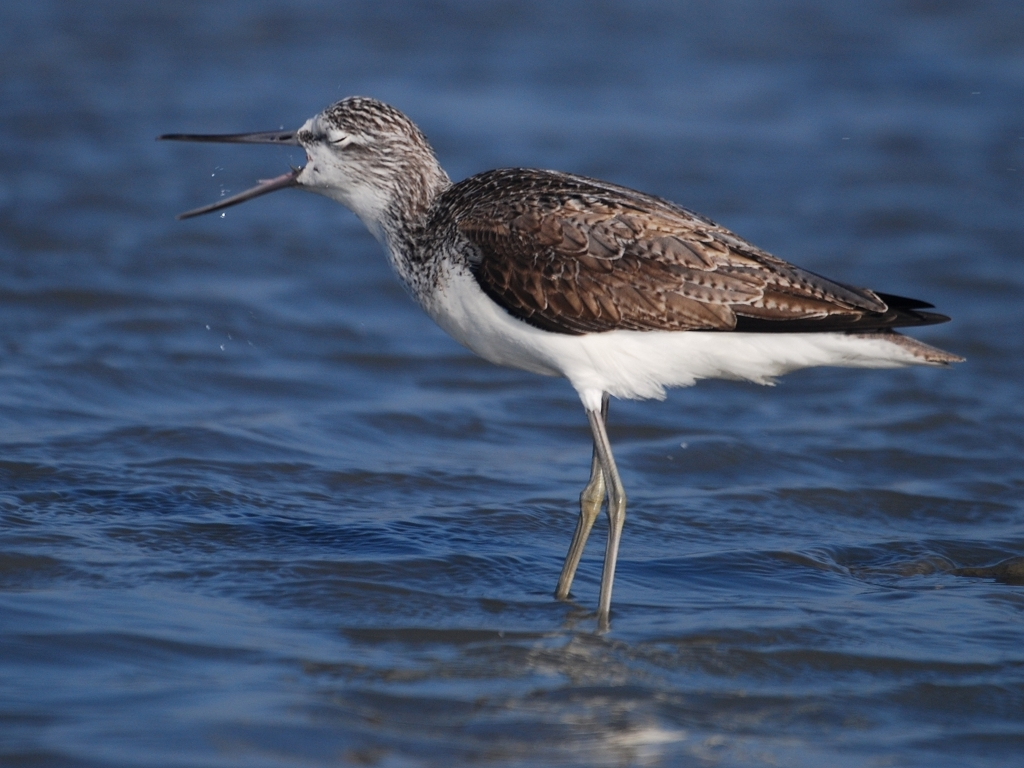What kind of bird is this? This is a Greyscale Tern, identifiable by its sharp beak and contrasting grey and white plumage. 